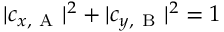Convert formula to latex. <formula><loc_0><loc_0><loc_500><loc_500>| c _ { x , A } | ^ { 2 } + | c _ { y , B } | ^ { 2 } = 1</formula> 